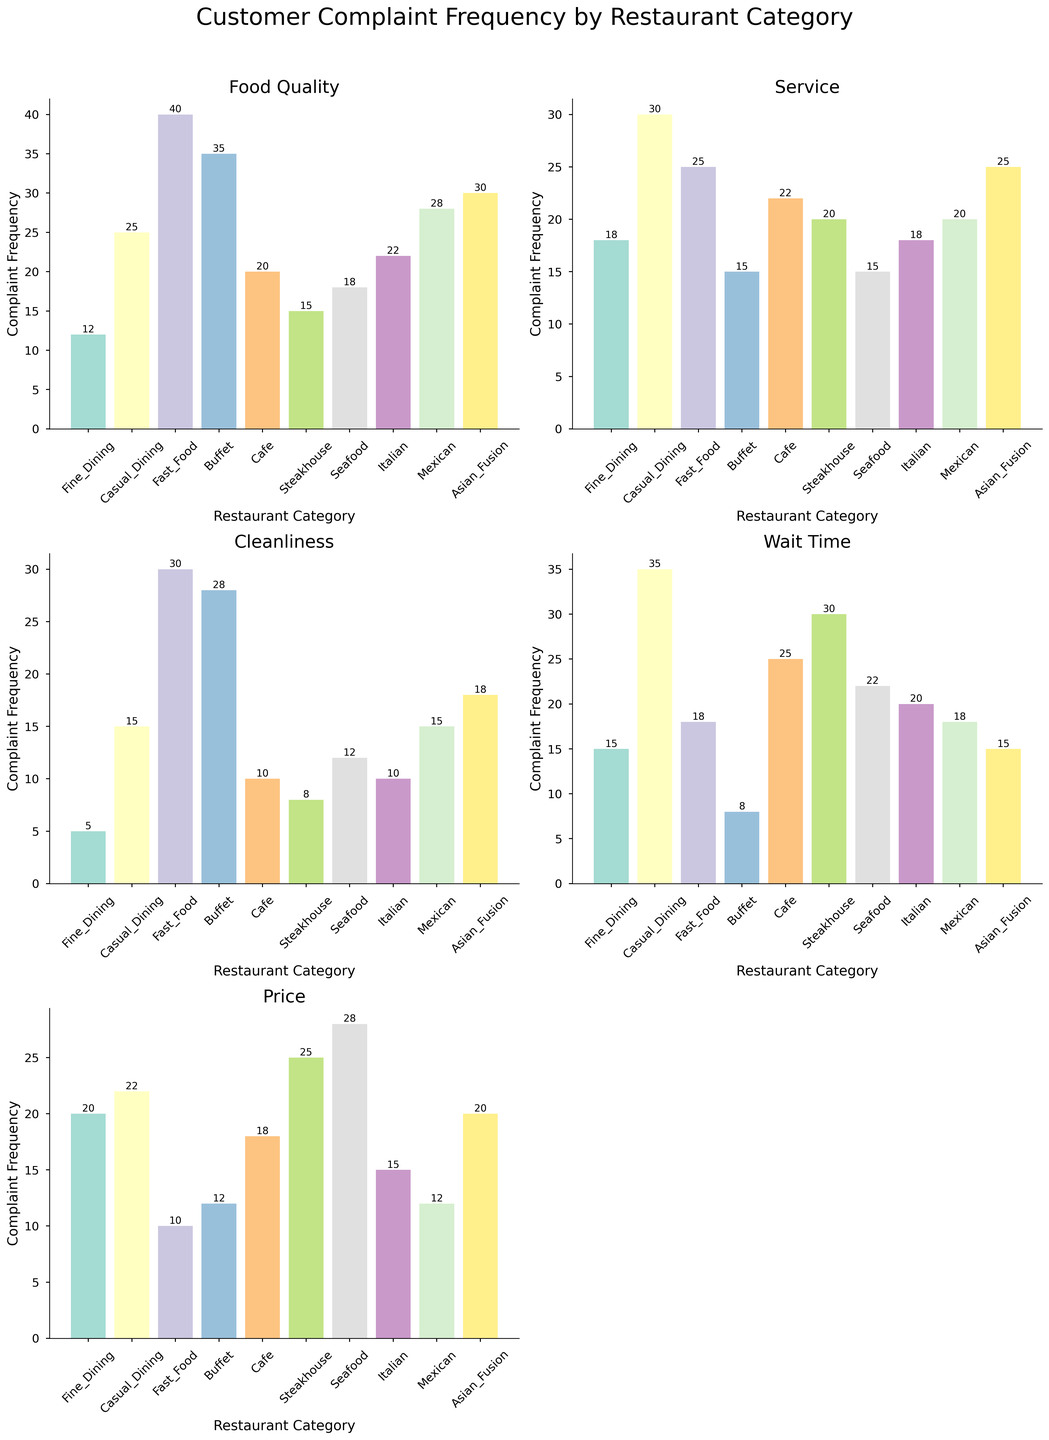What is the title of the figure? The title is located at the top of the figure. It reads "Customer Complaint Frequency by Restaurant Category".
Answer: Customer Complaint Frequency by Restaurant Category Which issue type has the highest complaint frequency in Fine Dining? Look at the bar corresponding to Fine Dining for the highest value across all issue types. The tallest bar appears under the "Price" category which marks the highest frequency.
Answer: Price How many restaurant categories are displayed in each subplot? Counting the number of bars in any subplot reveals the number of unique categories. There are 10 bars corresponding to 10 restaurant categories.
Answer: 10 Which restaurant category has the lowest number of complaints related to Cleanliness? In the Cleanliness subplot, examine the bar heights and find the smallest one. The smallest bar in this subplot is Fine Dining.
Answer: Fine Dining Compare the number of complaints relating to Service and Wait Time for Fast Food. Which one is higher? Locate the bars for Fast Food under Service and Wait Time categories. The Service bar is at 25, and the Wait Time bar is at 18. Service complaints are higher.
Answer: Service How many more complaints does the Buffet category have for Food Quality compared to Cleanliness? For Buffet, Food Quality complaints are 35, and Cleanliness complaints are 28. Subtract Cleanliness from Food Quality (35 - 28). The figure is 7.
Answer: 7 Which issue type has the least complaints for the Seafood category? In the subplot for each issue type, find the bars for Seafood. Identify the smallest bar among them. The smallest bar for Seafood corresponds to Cleanliness at 12.
Answer: Cleanliness What's the average number of complaints for the Mexican category across all issue types? Sum all the complaints for Mexican category (28 + 20 + 15 + 18 + 12) = 93, then divide by the number of issues which is 5. The average is 93 / 5 = 18.6
Answer: 18.6 Which restaurant has the highest complaint frequency overall in Price issues? In the Price subplot, identify the tallest bar. The tallest bar for Price issues is Seafood at 28.
Answer: Seafood 